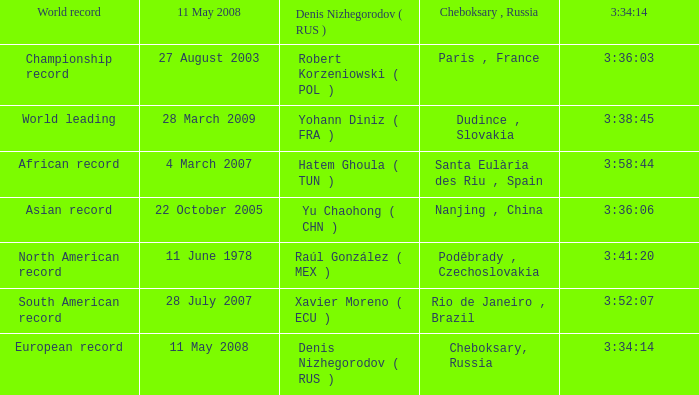When 3:41:20 is  3:34:14 what is cheboksary , russia? Poděbrady , Czechoslovakia. 